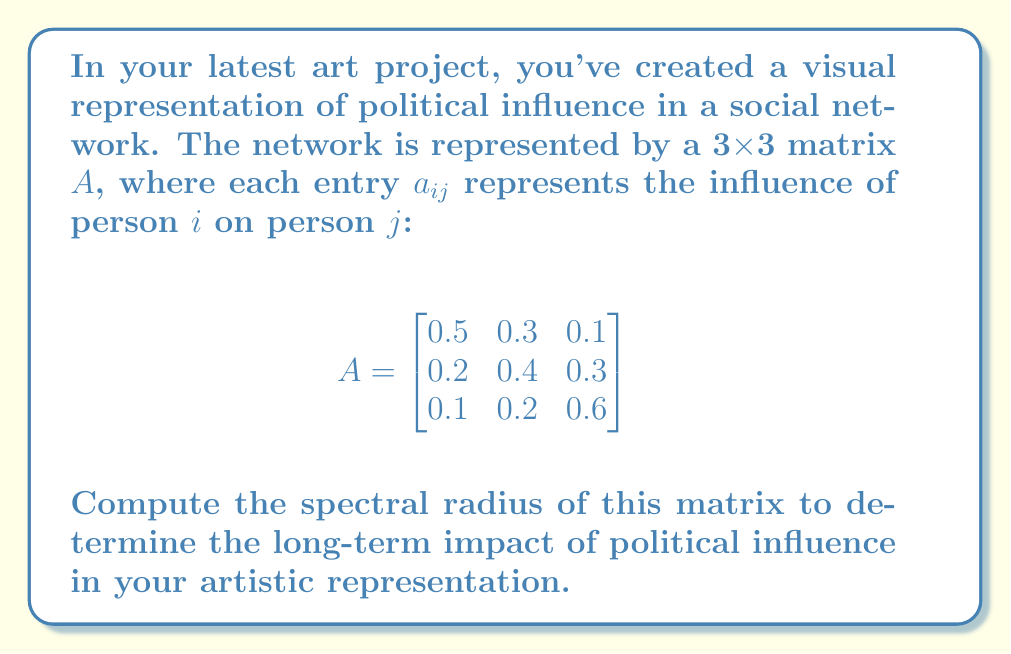Show me your answer to this math problem. To find the spectral radius of matrix A, we need to follow these steps:

1) First, we need to find the eigenvalues of A. The characteristic equation is:

   $\det(A - \lambda I) = 0$

2) Expanding this:

   $$\begin{vmatrix}
   0.5-\lambda & 0.3 & 0.1 \\
   0.2 & 0.4-\lambda & 0.3 \\
   0.1 & 0.2 & 0.6-\lambda
   \end{vmatrix} = 0$$

3) This gives us the cubic equation:

   $-\lambda^3 + 1.5\lambda^2 - 0.65\lambda + 0.082 = 0$

4) Solving this equation (using a computer algebra system or numerical methods), we get the eigenvalues:

   $\lambda_1 \approx 0.9397$
   $\lambda_2 \approx 0.3162$
   $\lambda_3 \approx 0.2441$

5) The spectral radius $\rho(A)$ is the maximum absolute value of the eigenvalues:

   $\rho(A) = \max(|\lambda_1|, |\lambda_2|, |\lambda_3|) = |\lambda_1| \approx 0.9397$

This value represents the long-term growth rate of influence in your artistic representation of the social network.
Answer: $\rho(A) \approx 0.9397$ 